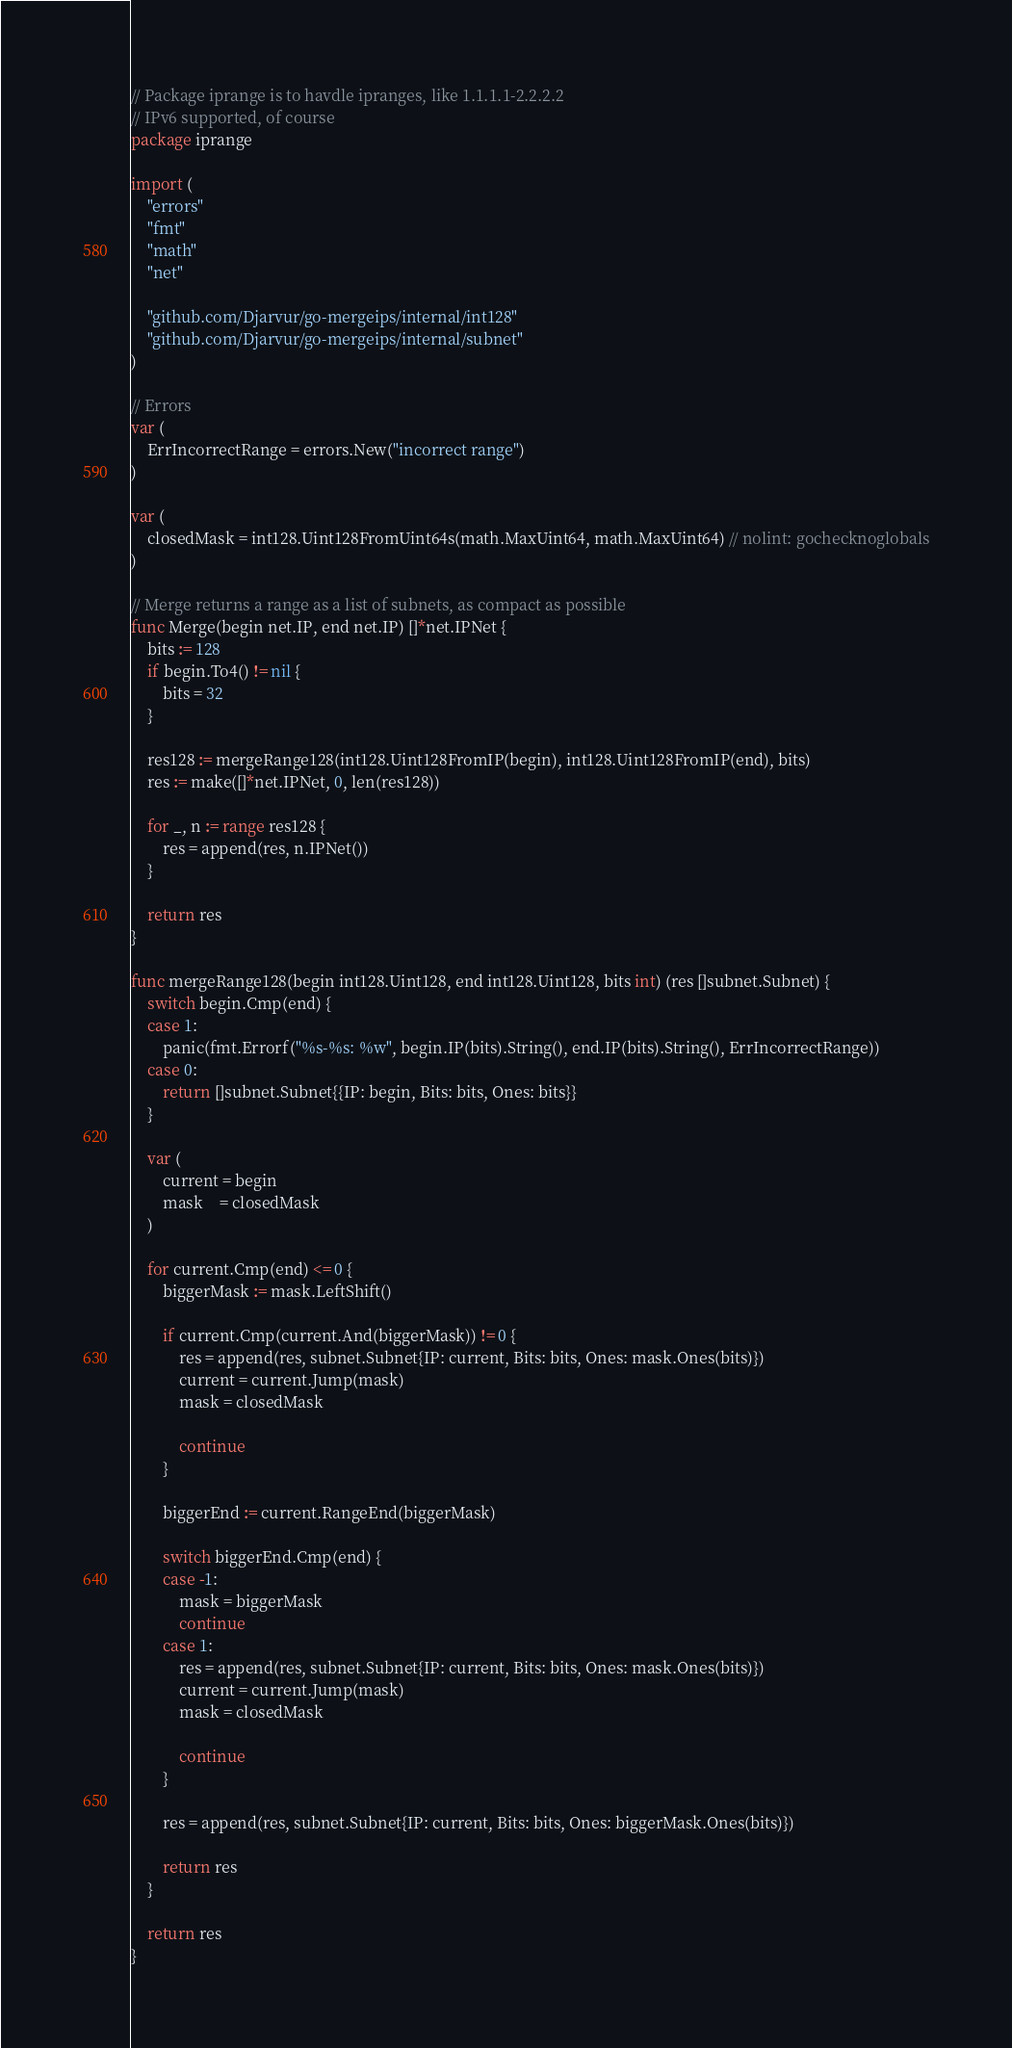<code> <loc_0><loc_0><loc_500><loc_500><_Go_>// Package iprange is to havdle ipranges, like 1.1.1.1-2.2.2.2
// IPv6 supported, of course
package iprange

import (
	"errors"
	"fmt"
	"math"
	"net"

	"github.com/Djarvur/go-mergeips/internal/int128"
	"github.com/Djarvur/go-mergeips/internal/subnet"
)

// Errors
var (
	ErrIncorrectRange = errors.New("incorrect range")
)

var (
	closedMask = int128.Uint128FromUint64s(math.MaxUint64, math.MaxUint64) // nolint: gochecknoglobals
)

// Merge returns a range as a list of subnets, as compact as possible
func Merge(begin net.IP, end net.IP) []*net.IPNet {
	bits := 128
	if begin.To4() != nil {
		bits = 32
	}

	res128 := mergeRange128(int128.Uint128FromIP(begin), int128.Uint128FromIP(end), bits)
	res := make([]*net.IPNet, 0, len(res128))

	for _, n := range res128 {
		res = append(res, n.IPNet())
	}

	return res
}

func mergeRange128(begin int128.Uint128, end int128.Uint128, bits int) (res []subnet.Subnet) {
	switch begin.Cmp(end) {
	case 1:
		panic(fmt.Errorf("%s-%s: %w", begin.IP(bits).String(), end.IP(bits).String(), ErrIncorrectRange))
	case 0:
		return []subnet.Subnet{{IP: begin, Bits: bits, Ones: bits}}
	}

	var (
		current = begin
		mask    = closedMask
	)

	for current.Cmp(end) <= 0 {
		biggerMask := mask.LeftShift()

		if current.Cmp(current.And(biggerMask)) != 0 {
			res = append(res, subnet.Subnet{IP: current, Bits: bits, Ones: mask.Ones(bits)})
			current = current.Jump(mask)
			mask = closedMask

			continue
		}

		biggerEnd := current.RangeEnd(biggerMask)

		switch biggerEnd.Cmp(end) {
		case -1:
			mask = biggerMask
			continue
		case 1:
			res = append(res, subnet.Subnet{IP: current, Bits: bits, Ones: mask.Ones(bits)})
			current = current.Jump(mask)
			mask = closedMask

			continue
		}

		res = append(res, subnet.Subnet{IP: current, Bits: bits, Ones: biggerMask.Ones(bits)})

		return res
	}

	return res
}
</code> 